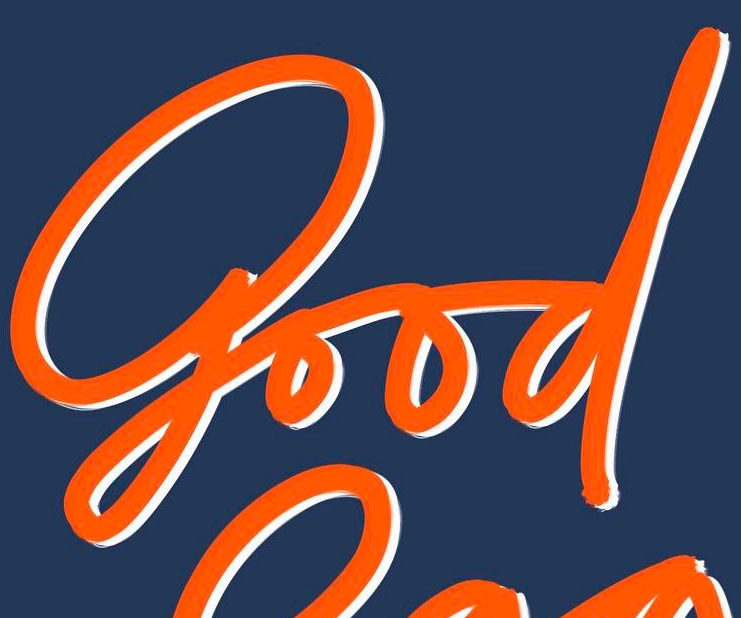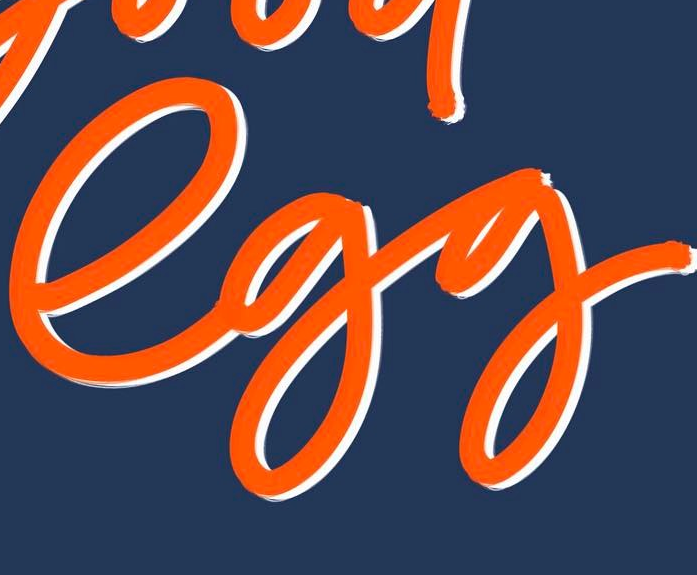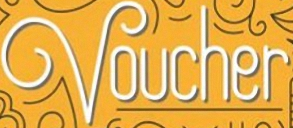Transcribe the words shown in these images in order, separated by a semicolon. good; egg; Voucher 